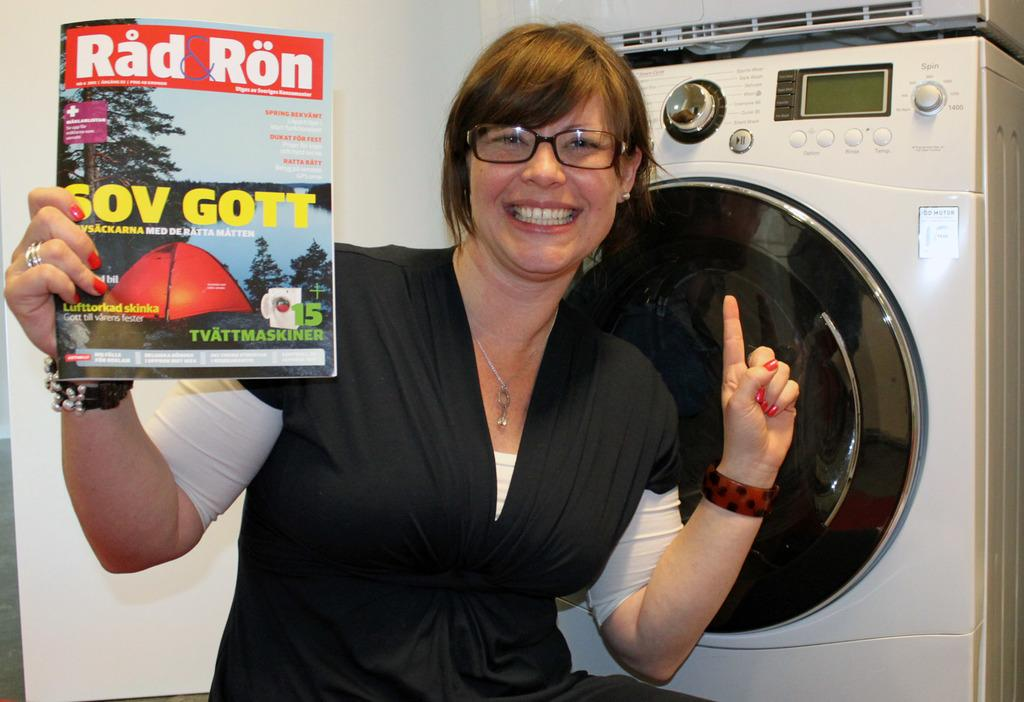<image>
Offer a succinct explanation of the picture presented. A Rad Ron magazine held up by a smiling lady. 